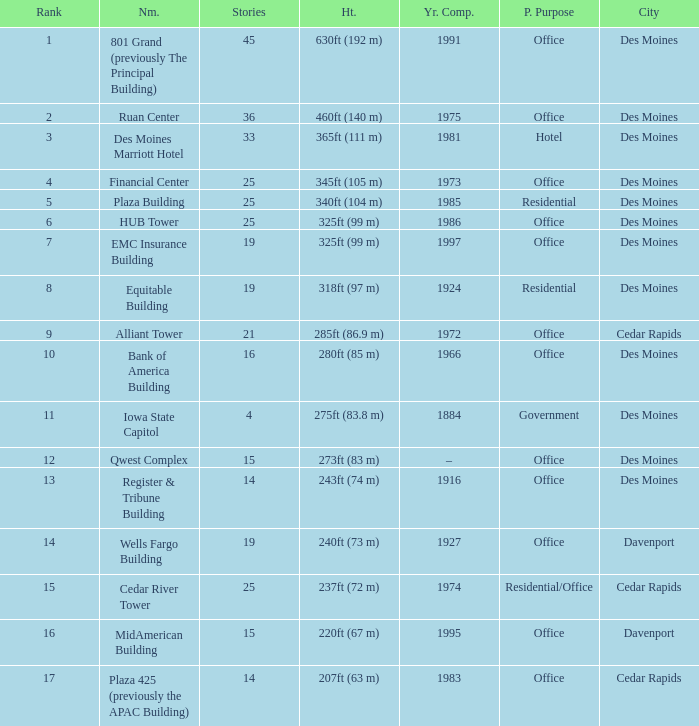What is the elevation of the emc insurance building in des moines? 325ft (99 m). Could you parse the entire table as a dict? {'header': ['Rank', 'Nm.', 'Stories', 'Ht.', 'Yr. Comp.', 'P. Purpose', 'City'], 'rows': [['1', '801 Grand (previously The Principal Building)', '45', '630ft (192 m)', '1991', 'Office', 'Des Moines'], ['2', 'Ruan Center', '36', '460ft (140 m)', '1975', 'Office', 'Des Moines'], ['3', 'Des Moines Marriott Hotel', '33', '365ft (111 m)', '1981', 'Hotel', 'Des Moines'], ['4', 'Financial Center', '25', '345ft (105 m)', '1973', 'Office', 'Des Moines'], ['5', 'Plaza Building', '25', '340ft (104 m)', '1985', 'Residential', 'Des Moines'], ['6', 'HUB Tower', '25', '325ft (99 m)', '1986', 'Office', 'Des Moines'], ['7', 'EMC Insurance Building', '19', '325ft (99 m)', '1997', 'Office', 'Des Moines'], ['8', 'Equitable Building', '19', '318ft (97 m)', '1924', 'Residential', 'Des Moines'], ['9', 'Alliant Tower', '21', '285ft (86.9 m)', '1972', 'Office', 'Cedar Rapids'], ['10', 'Bank of America Building', '16', '280ft (85 m)', '1966', 'Office', 'Des Moines'], ['11', 'Iowa State Capitol', '4', '275ft (83.8 m)', '1884', 'Government', 'Des Moines'], ['12', 'Qwest Complex', '15', '273ft (83 m)', '–', 'Office', 'Des Moines'], ['13', 'Register & Tribune Building', '14', '243ft (74 m)', '1916', 'Office', 'Des Moines'], ['14', 'Wells Fargo Building', '19', '240ft (73 m)', '1927', 'Office', 'Davenport'], ['15', 'Cedar River Tower', '25', '237ft (72 m)', '1974', 'Residential/Office', 'Cedar Rapids'], ['16', 'MidAmerican Building', '15', '220ft (67 m)', '1995', 'Office', 'Davenport'], ['17', 'Plaza 425 (previously the APAC Building)', '14', '207ft (63 m)', '1983', 'Office', 'Cedar Rapids']]} 